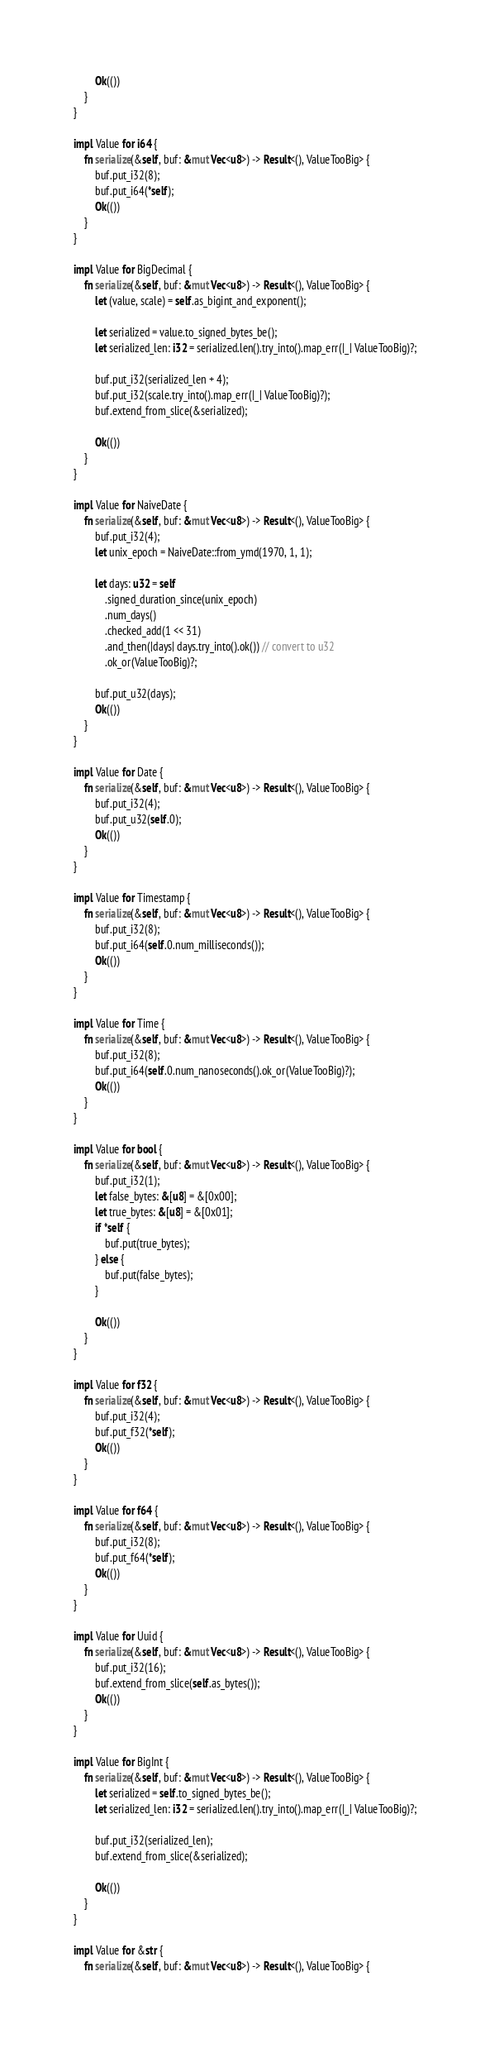<code> <loc_0><loc_0><loc_500><loc_500><_Rust_>        Ok(())
    }
}

impl Value for i64 {
    fn serialize(&self, buf: &mut Vec<u8>) -> Result<(), ValueTooBig> {
        buf.put_i32(8);
        buf.put_i64(*self);
        Ok(())
    }
}

impl Value for BigDecimal {
    fn serialize(&self, buf: &mut Vec<u8>) -> Result<(), ValueTooBig> {
        let (value, scale) = self.as_bigint_and_exponent();

        let serialized = value.to_signed_bytes_be();
        let serialized_len: i32 = serialized.len().try_into().map_err(|_| ValueTooBig)?;

        buf.put_i32(serialized_len + 4);
        buf.put_i32(scale.try_into().map_err(|_| ValueTooBig)?);
        buf.extend_from_slice(&serialized);

        Ok(())
    }
}

impl Value for NaiveDate {
    fn serialize(&self, buf: &mut Vec<u8>) -> Result<(), ValueTooBig> {
        buf.put_i32(4);
        let unix_epoch = NaiveDate::from_ymd(1970, 1, 1);

        let days: u32 = self
            .signed_duration_since(unix_epoch)
            .num_days()
            .checked_add(1 << 31)
            .and_then(|days| days.try_into().ok()) // convert to u32
            .ok_or(ValueTooBig)?;

        buf.put_u32(days);
        Ok(())
    }
}

impl Value for Date {
    fn serialize(&self, buf: &mut Vec<u8>) -> Result<(), ValueTooBig> {
        buf.put_i32(4);
        buf.put_u32(self.0);
        Ok(())
    }
}

impl Value for Timestamp {
    fn serialize(&self, buf: &mut Vec<u8>) -> Result<(), ValueTooBig> {
        buf.put_i32(8);
        buf.put_i64(self.0.num_milliseconds());
        Ok(())
    }
}

impl Value for Time {
    fn serialize(&self, buf: &mut Vec<u8>) -> Result<(), ValueTooBig> {
        buf.put_i32(8);
        buf.put_i64(self.0.num_nanoseconds().ok_or(ValueTooBig)?);
        Ok(())
    }
}

impl Value for bool {
    fn serialize(&self, buf: &mut Vec<u8>) -> Result<(), ValueTooBig> {
        buf.put_i32(1);
        let false_bytes: &[u8] = &[0x00];
        let true_bytes: &[u8] = &[0x01];
        if *self {
            buf.put(true_bytes);
        } else {
            buf.put(false_bytes);
        }

        Ok(())
    }
}

impl Value for f32 {
    fn serialize(&self, buf: &mut Vec<u8>) -> Result<(), ValueTooBig> {
        buf.put_i32(4);
        buf.put_f32(*self);
        Ok(())
    }
}

impl Value for f64 {
    fn serialize(&self, buf: &mut Vec<u8>) -> Result<(), ValueTooBig> {
        buf.put_i32(8);
        buf.put_f64(*self);
        Ok(())
    }
}

impl Value for Uuid {
    fn serialize(&self, buf: &mut Vec<u8>) -> Result<(), ValueTooBig> {
        buf.put_i32(16);
        buf.extend_from_slice(self.as_bytes());
        Ok(())
    }
}

impl Value for BigInt {
    fn serialize(&self, buf: &mut Vec<u8>) -> Result<(), ValueTooBig> {
        let serialized = self.to_signed_bytes_be();
        let serialized_len: i32 = serialized.len().try_into().map_err(|_| ValueTooBig)?;

        buf.put_i32(serialized_len);
        buf.extend_from_slice(&serialized);

        Ok(())
    }
}

impl Value for &str {
    fn serialize(&self, buf: &mut Vec<u8>) -> Result<(), ValueTooBig> {</code> 